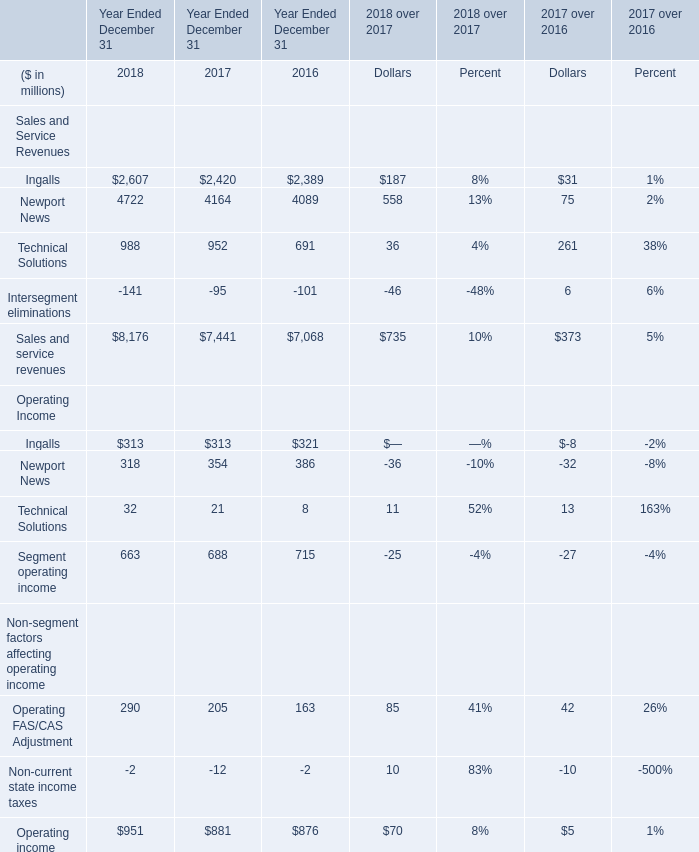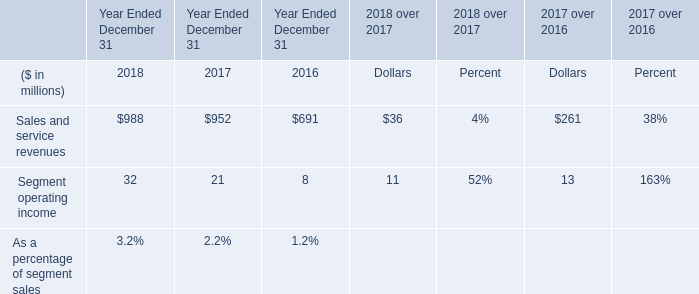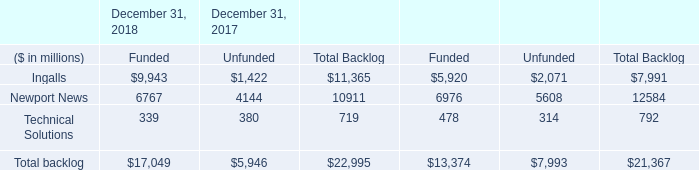What's the increasing rate of Technical Solutions for Sales and Service Revenues in 2017? 
Computations: ((952 - 691) / 691)
Answer: 0.37771. 